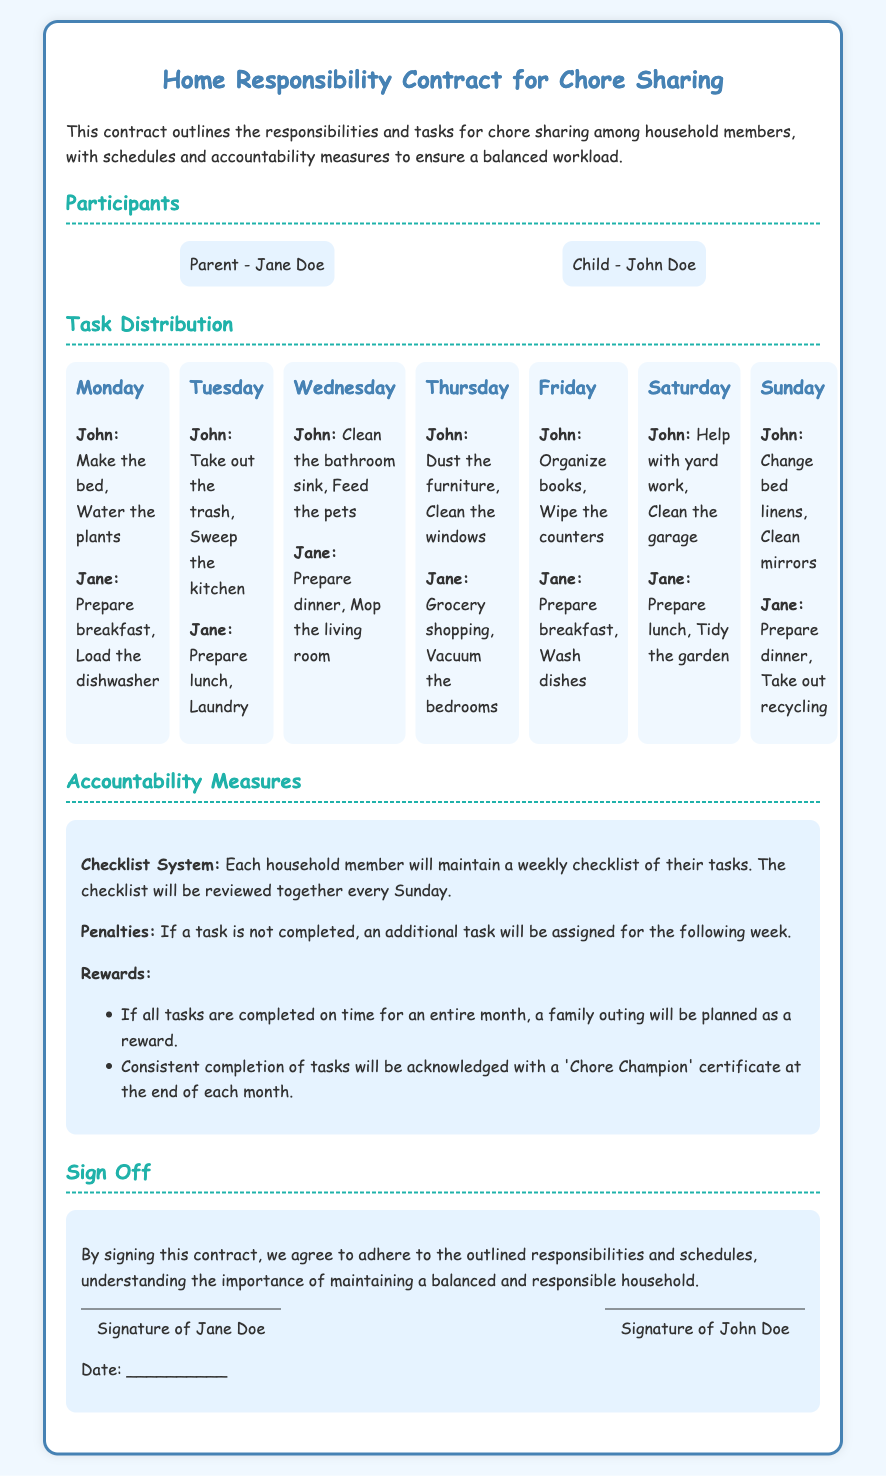What is the title of the contract? The title is explicitly stated at the top of the document.
Answer: Home Responsibility Contract for Chore Sharing Who are the participants in this contract? The participants are listed under the 'Participants' section.
Answer: Parent - Jane Doe, Child - John Doe What task is assigned to John on Wednesday? The tasks are specified under each day, particularly for Wednesday.
Answer: Clean the bathroom sink, Feed the pets What is the accountability measure regarding checklists? The accountability section discusses how the checklist will be used.
Answer: Each household member will maintain a weekly checklist of their tasks What reward is mentioned for consistent task completion? Rewards for task completion are listed in the accountability section.
Answer: Chore Champion certificate How many days of task distribution are outlined in the document? The number of days is indicated by the tasks assigned for each day of the week.
Answer: Seven What sign-off is required to agree to the responsibilities? The sign-off statement is found in the 'Sign Off' section.
Answer: Signature of Jane Doe, Signature of John Doe What happens if a task is not completed? The consequences of not completing a task are mentioned in the accountability section.
Answer: An additional task will be assigned for the following week 